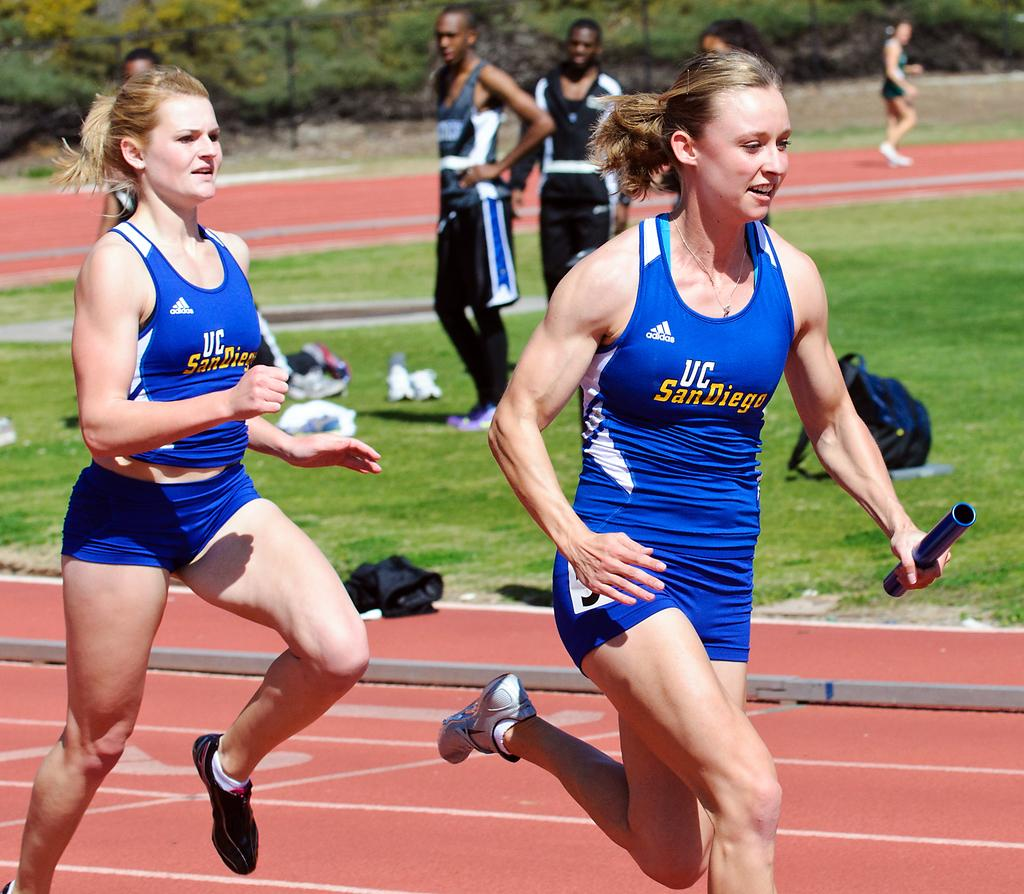Provide a one-sentence caption for the provided image. Female runners from UC San Diego on a track with 2 male runners watching. 